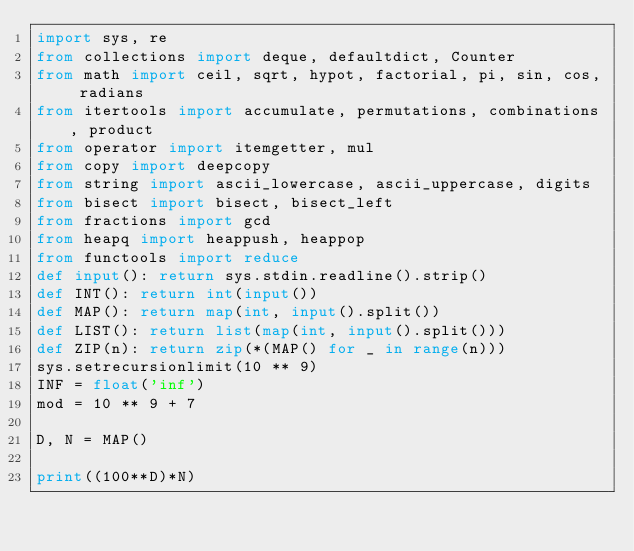<code> <loc_0><loc_0><loc_500><loc_500><_Python_>import sys, re
from collections import deque, defaultdict, Counter
from math import ceil, sqrt, hypot, factorial, pi, sin, cos, radians
from itertools import accumulate, permutations, combinations, product
from operator import itemgetter, mul
from copy import deepcopy
from string import ascii_lowercase, ascii_uppercase, digits
from bisect import bisect, bisect_left
from fractions import gcd
from heapq import heappush, heappop
from functools import reduce
def input(): return sys.stdin.readline().strip()
def INT(): return int(input())
def MAP(): return map(int, input().split())
def LIST(): return list(map(int, input().split()))
def ZIP(n): return zip(*(MAP() for _ in range(n)))
sys.setrecursionlimit(10 ** 9)
INF = float('inf')
mod = 10 ** 9 + 7

D, N = MAP()

print((100**D)*N)
</code> 